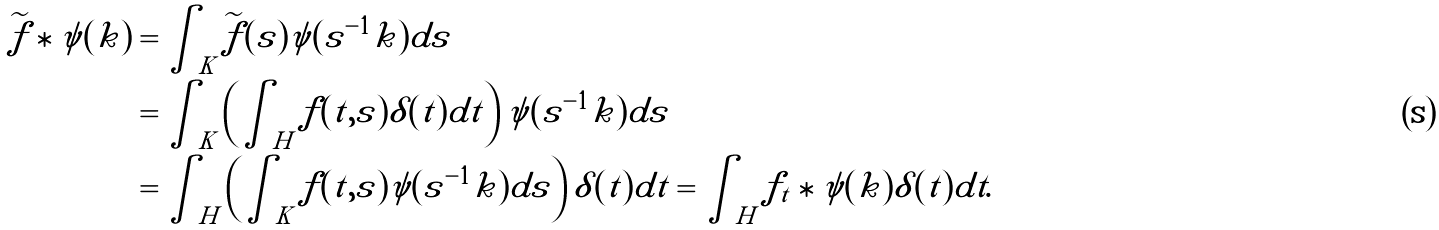<formula> <loc_0><loc_0><loc_500><loc_500>\widetilde { f } \ast \psi ( k ) & = \int _ { K } \widetilde { f } ( s ) \psi ( s ^ { - 1 } k ) d s \\ & = \int _ { K } \left ( \int _ { H } f ( t , s ) \delta ( t ) d t \right ) \psi ( s ^ { - 1 } k ) d s \\ & = \int _ { H } \left ( \int _ { K } f ( t , s ) \psi ( s ^ { - 1 } k ) d s \right ) \delta ( t ) d t = \int _ { H } f _ { t } \ast \psi ( k ) \delta ( t ) d t .</formula> 